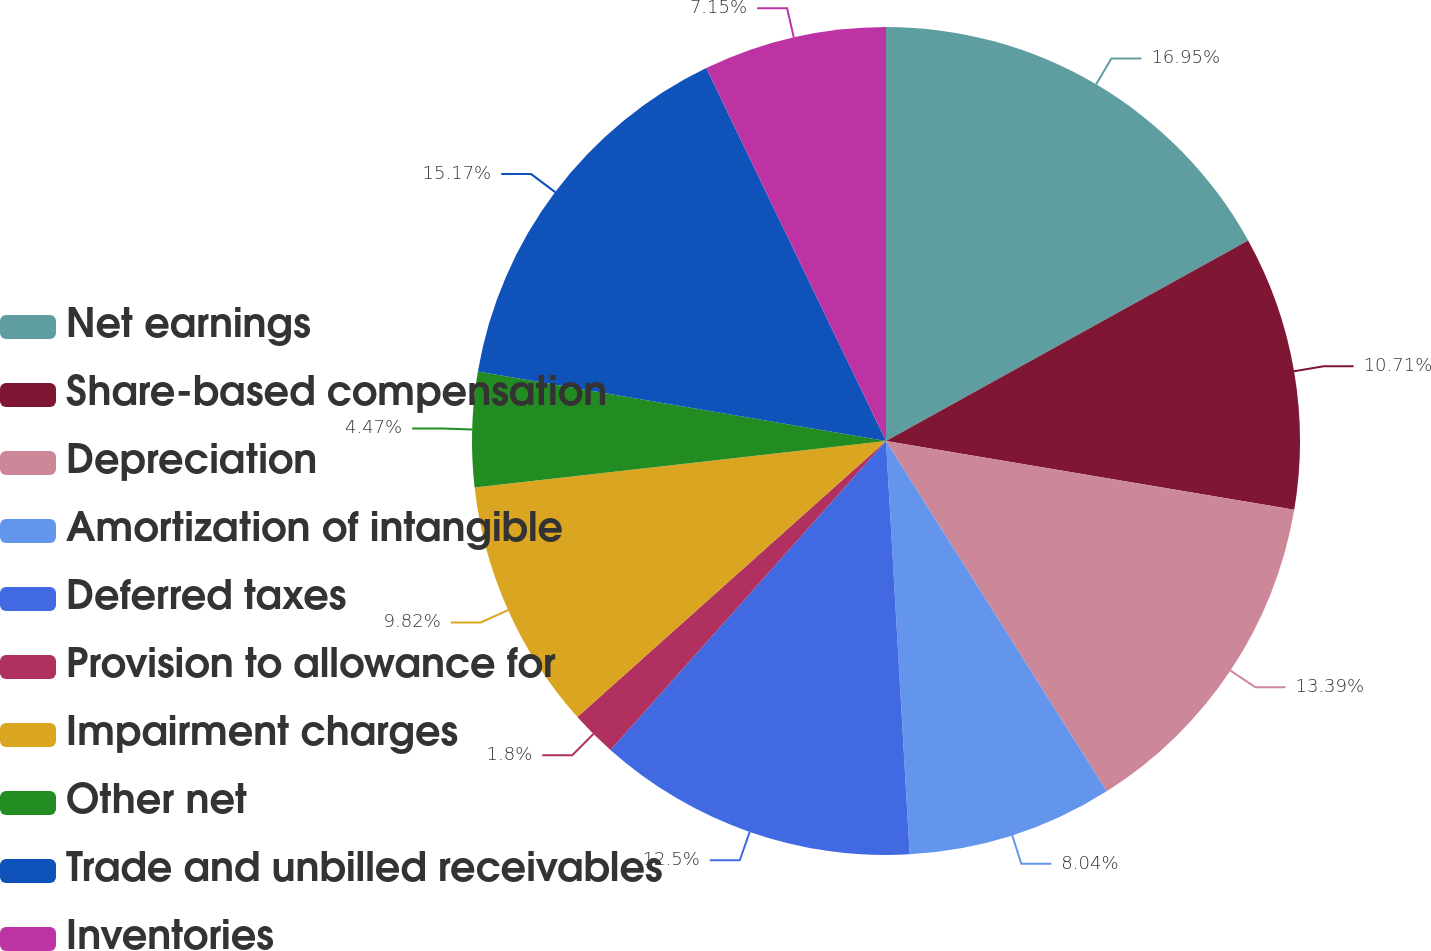Convert chart to OTSL. <chart><loc_0><loc_0><loc_500><loc_500><pie_chart><fcel>Net earnings<fcel>Share-based compensation<fcel>Depreciation<fcel>Amortization of intangible<fcel>Deferred taxes<fcel>Provision to allowance for<fcel>Impairment charges<fcel>Other net<fcel>Trade and unbilled receivables<fcel>Inventories<nl><fcel>16.95%<fcel>10.71%<fcel>13.39%<fcel>8.04%<fcel>12.5%<fcel>1.8%<fcel>9.82%<fcel>4.47%<fcel>15.17%<fcel>7.15%<nl></chart> 